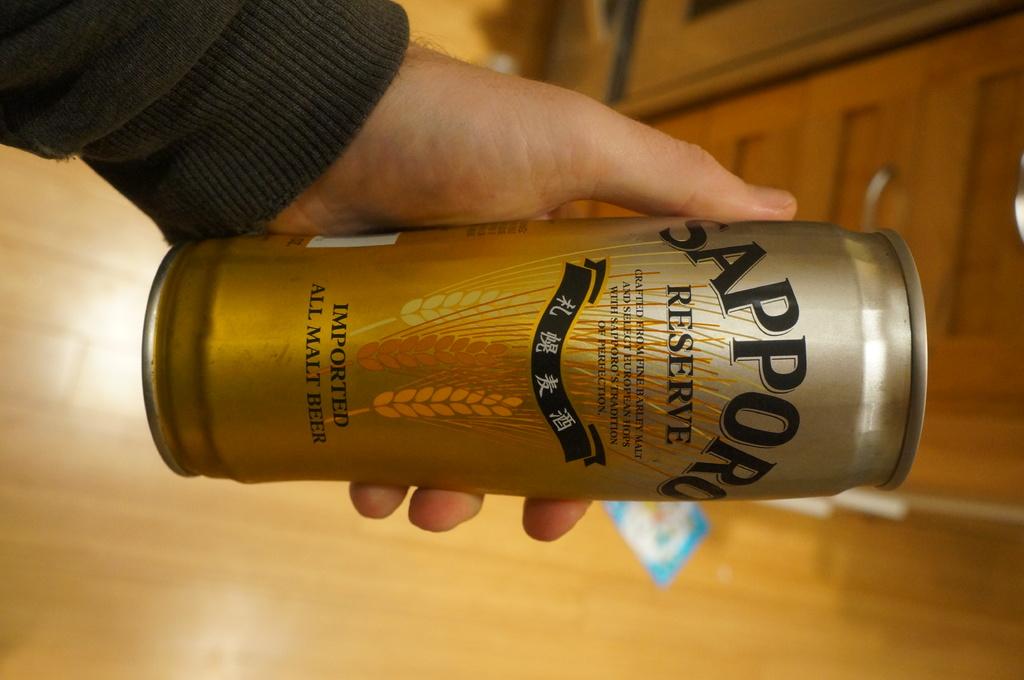What type of beverage is in this can?
Give a very brief answer. All malt beer. 